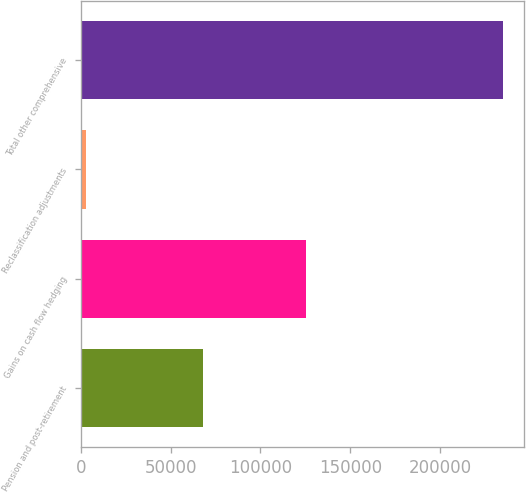Convert chart. <chart><loc_0><loc_0><loc_500><loc_500><bar_chart><fcel>Pension and post-retirement<fcel>Gains on cash flow hedging<fcel>Reclassification adjustments<fcel>Total other comprehensive<nl><fcel>68217<fcel>125198<fcel>3014<fcel>234731<nl></chart> 